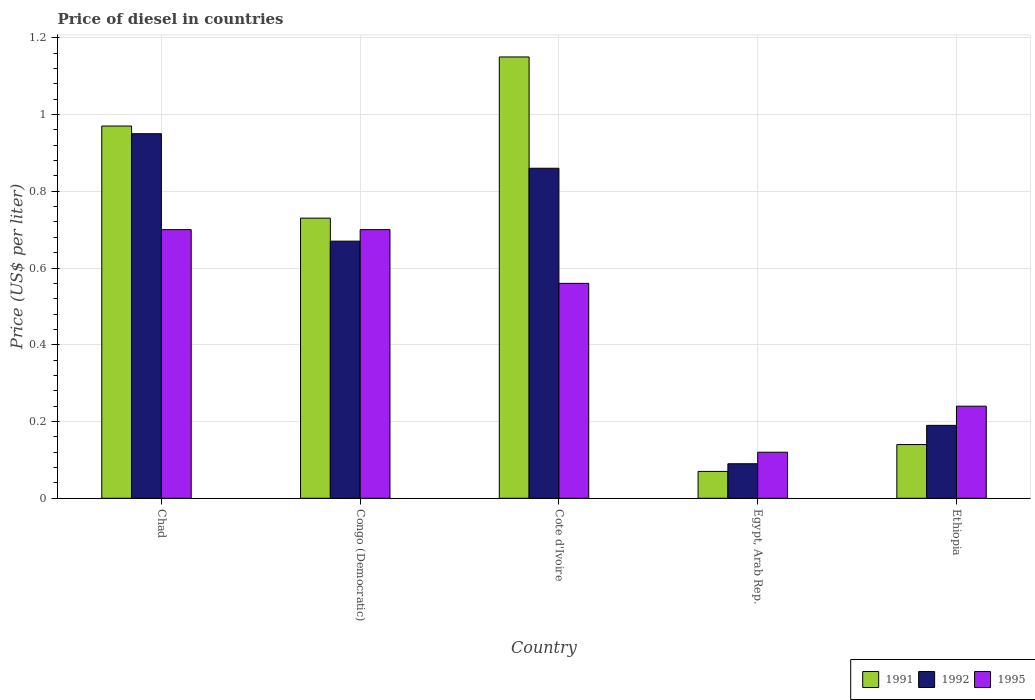How many different coloured bars are there?
Your answer should be very brief. 3. How many groups of bars are there?
Give a very brief answer. 5. Are the number of bars on each tick of the X-axis equal?
Your answer should be very brief. Yes. How many bars are there on the 4th tick from the left?
Keep it short and to the point. 3. How many bars are there on the 5th tick from the right?
Your answer should be compact. 3. What is the label of the 2nd group of bars from the left?
Provide a short and direct response. Congo (Democratic). In how many cases, is the number of bars for a given country not equal to the number of legend labels?
Offer a very short reply. 0. What is the price of diesel in 1995 in Egypt, Arab Rep.?
Your answer should be compact. 0.12. Across all countries, what is the minimum price of diesel in 1991?
Offer a very short reply. 0.07. In which country was the price of diesel in 1992 maximum?
Offer a very short reply. Chad. In which country was the price of diesel in 1991 minimum?
Your answer should be very brief. Egypt, Arab Rep. What is the total price of diesel in 1995 in the graph?
Offer a terse response. 2.32. What is the difference between the price of diesel in 1995 in Cote d'Ivoire and that in Egypt, Arab Rep.?
Offer a terse response. 0.44. What is the difference between the price of diesel in 1992 in Congo (Democratic) and the price of diesel in 1991 in Chad?
Ensure brevity in your answer.  -0.3. What is the average price of diesel in 1991 per country?
Offer a terse response. 0.61. What is the difference between the price of diesel of/in 1991 and price of diesel of/in 1992 in Cote d'Ivoire?
Keep it short and to the point. 0.29. In how many countries, is the price of diesel in 1991 greater than 0.12 US$?
Provide a succinct answer. 4. What is the ratio of the price of diesel in 1991 in Chad to that in Ethiopia?
Your answer should be very brief. 6.93. What is the difference between the highest and the second highest price of diesel in 1995?
Provide a short and direct response. 0.14. What is the difference between the highest and the lowest price of diesel in 1992?
Provide a short and direct response. 0.86. In how many countries, is the price of diesel in 1991 greater than the average price of diesel in 1991 taken over all countries?
Provide a succinct answer. 3. What does the 2nd bar from the left in Ethiopia represents?
Offer a very short reply. 1992. How many bars are there?
Offer a very short reply. 15. How many countries are there in the graph?
Make the answer very short. 5. What is the difference between two consecutive major ticks on the Y-axis?
Offer a very short reply. 0.2. How are the legend labels stacked?
Offer a very short reply. Horizontal. What is the title of the graph?
Keep it short and to the point. Price of diesel in countries. Does "2008" appear as one of the legend labels in the graph?
Make the answer very short. No. What is the label or title of the Y-axis?
Offer a terse response. Price (US$ per liter). What is the Price (US$ per liter) of 1991 in Chad?
Offer a very short reply. 0.97. What is the Price (US$ per liter) of 1992 in Chad?
Your answer should be compact. 0.95. What is the Price (US$ per liter) in 1991 in Congo (Democratic)?
Make the answer very short. 0.73. What is the Price (US$ per liter) in 1992 in Congo (Democratic)?
Keep it short and to the point. 0.67. What is the Price (US$ per liter) in 1995 in Congo (Democratic)?
Provide a succinct answer. 0.7. What is the Price (US$ per liter) of 1991 in Cote d'Ivoire?
Make the answer very short. 1.15. What is the Price (US$ per liter) of 1992 in Cote d'Ivoire?
Offer a terse response. 0.86. What is the Price (US$ per liter) in 1995 in Cote d'Ivoire?
Your answer should be compact. 0.56. What is the Price (US$ per liter) of 1991 in Egypt, Arab Rep.?
Your answer should be compact. 0.07. What is the Price (US$ per liter) in 1992 in Egypt, Arab Rep.?
Give a very brief answer. 0.09. What is the Price (US$ per liter) of 1995 in Egypt, Arab Rep.?
Make the answer very short. 0.12. What is the Price (US$ per liter) of 1991 in Ethiopia?
Provide a short and direct response. 0.14. What is the Price (US$ per liter) of 1992 in Ethiopia?
Offer a very short reply. 0.19. What is the Price (US$ per liter) of 1995 in Ethiopia?
Make the answer very short. 0.24. Across all countries, what is the maximum Price (US$ per liter) in 1991?
Ensure brevity in your answer.  1.15. Across all countries, what is the minimum Price (US$ per liter) in 1991?
Offer a very short reply. 0.07. Across all countries, what is the minimum Price (US$ per liter) of 1992?
Provide a short and direct response. 0.09. Across all countries, what is the minimum Price (US$ per liter) in 1995?
Your answer should be compact. 0.12. What is the total Price (US$ per liter) in 1991 in the graph?
Provide a short and direct response. 3.06. What is the total Price (US$ per liter) in 1992 in the graph?
Provide a short and direct response. 2.76. What is the total Price (US$ per liter) of 1995 in the graph?
Give a very brief answer. 2.32. What is the difference between the Price (US$ per liter) of 1991 in Chad and that in Congo (Democratic)?
Provide a short and direct response. 0.24. What is the difference between the Price (US$ per liter) in 1992 in Chad and that in Congo (Democratic)?
Provide a succinct answer. 0.28. What is the difference between the Price (US$ per liter) of 1991 in Chad and that in Cote d'Ivoire?
Provide a short and direct response. -0.18. What is the difference between the Price (US$ per liter) of 1992 in Chad and that in Cote d'Ivoire?
Your answer should be very brief. 0.09. What is the difference between the Price (US$ per liter) in 1995 in Chad and that in Cote d'Ivoire?
Your answer should be compact. 0.14. What is the difference between the Price (US$ per liter) of 1991 in Chad and that in Egypt, Arab Rep.?
Your answer should be very brief. 0.9. What is the difference between the Price (US$ per liter) in 1992 in Chad and that in Egypt, Arab Rep.?
Provide a succinct answer. 0.86. What is the difference between the Price (US$ per liter) in 1995 in Chad and that in Egypt, Arab Rep.?
Offer a terse response. 0.58. What is the difference between the Price (US$ per liter) of 1991 in Chad and that in Ethiopia?
Make the answer very short. 0.83. What is the difference between the Price (US$ per liter) in 1992 in Chad and that in Ethiopia?
Give a very brief answer. 0.76. What is the difference between the Price (US$ per liter) in 1995 in Chad and that in Ethiopia?
Your answer should be very brief. 0.46. What is the difference between the Price (US$ per liter) in 1991 in Congo (Democratic) and that in Cote d'Ivoire?
Offer a terse response. -0.42. What is the difference between the Price (US$ per liter) of 1992 in Congo (Democratic) and that in Cote d'Ivoire?
Ensure brevity in your answer.  -0.19. What is the difference between the Price (US$ per liter) of 1995 in Congo (Democratic) and that in Cote d'Ivoire?
Offer a very short reply. 0.14. What is the difference between the Price (US$ per liter) in 1991 in Congo (Democratic) and that in Egypt, Arab Rep.?
Your answer should be very brief. 0.66. What is the difference between the Price (US$ per liter) of 1992 in Congo (Democratic) and that in Egypt, Arab Rep.?
Offer a terse response. 0.58. What is the difference between the Price (US$ per liter) of 1995 in Congo (Democratic) and that in Egypt, Arab Rep.?
Provide a succinct answer. 0.58. What is the difference between the Price (US$ per liter) of 1991 in Congo (Democratic) and that in Ethiopia?
Provide a short and direct response. 0.59. What is the difference between the Price (US$ per liter) of 1992 in Congo (Democratic) and that in Ethiopia?
Provide a succinct answer. 0.48. What is the difference between the Price (US$ per liter) in 1995 in Congo (Democratic) and that in Ethiopia?
Offer a terse response. 0.46. What is the difference between the Price (US$ per liter) of 1991 in Cote d'Ivoire and that in Egypt, Arab Rep.?
Your response must be concise. 1.08. What is the difference between the Price (US$ per liter) in 1992 in Cote d'Ivoire and that in Egypt, Arab Rep.?
Keep it short and to the point. 0.77. What is the difference between the Price (US$ per liter) of 1995 in Cote d'Ivoire and that in Egypt, Arab Rep.?
Keep it short and to the point. 0.44. What is the difference between the Price (US$ per liter) in 1992 in Cote d'Ivoire and that in Ethiopia?
Keep it short and to the point. 0.67. What is the difference between the Price (US$ per liter) in 1995 in Cote d'Ivoire and that in Ethiopia?
Offer a very short reply. 0.32. What is the difference between the Price (US$ per liter) in 1991 in Egypt, Arab Rep. and that in Ethiopia?
Your answer should be compact. -0.07. What is the difference between the Price (US$ per liter) in 1995 in Egypt, Arab Rep. and that in Ethiopia?
Provide a succinct answer. -0.12. What is the difference between the Price (US$ per liter) of 1991 in Chad and the Price (US$ per liter) of 1995 in Congo (Democratic)?
Your answer should be very brief. 0.27. What is the difference between the Price (US$ per liter) in 1992 in Chad and the Price (US$ per liter) in 1995 in Congo (Democratic)?
Ensure brevity in your answer.  0.25. What is the difference between the Price (US$ per liter) in 1991 in Chad and the Price (US$ per liter) in 1992 in Cote d'Ivoire?
Your answer should be compact. 0.11. What is the difference between the Price (US$ per liter) in 1991 in Chad and the Price (US$ per liter) in 1995 in Cote d'Ivoire?
Your answer should be compact. 0.41. What is the difference between the Price (US$ per liter) in 1992 in Chad and the Price (US$ per liter) in 1995 in Cote d'Ivoire?
Your response must be concise. 0.39. What is the difference between the Price (US$ per liter) of 1991 in Chad and the Price (US$ per liter) of 1992 in Egypt, Arab Rep.?
Provide a short and direct response. 0.88. What is the difference between the Price (US$ per liter) in 1991 in Chad and the Price (US$ per liter) in 1995 in Egypt, Arab Rep.?
Your answer should be very brief. 0.85. What is the difference between the Price (US$ per liter) of 1992 in Chad and the Price (US$ per liter) of 1995 in Egypt, Arab Rep.?
Provide a succinct answer. 0.83. What is the difference between the Price (US$ per liter) of 1991 in Chad and the Price (US$ per liter) of 1992 in Ethiopia?
Provide a short and direct response. 0.78. What is the difference between the Price (US$ per liter) of 1991 in Chad and the Price (US$ per liter) of 1995 in Ethiopia?
Offer a very short reply. 0.73. What is the difference between the Price (US$ per liter) in 1992 in Chad and the Price (US$ per liter) in 1995 in Ethiopia?
Make the answer very short. 0.71. What is the difference between the Price (US$ per liter) in 1991 in Congo (Democratic) and the Price (US$ per liter) in 1992 in Cote d'Ivoire?
Your response must be concise. -0.13. What is the difference between the Price (US$ per liter) of 1991 in Congo (Democratic) and the Price (US$ per liter) of 1995 in Cote d'Ivoire?
Provide a short and direct response. 0.17. What is the difference between the Price (US$ per liter) in 1992 in Congo (Democratic) and the Price (US$ per liter) in 1995 in Cote d'Ivoire?
Your response must be concise. 0.11. What is the difference between the Price (US$ per liter) in 1991 in Congo (Democratic) and the Price (US$ per liter) in 1992 in Egypt, Arab Rep.?
Provide a short and direct response. 0.64. What is the difference between the Price (US$ per liter) of 1991 in Congo (Democratic) and the Price (US$ per liter) of 1995 in Egypt, Arab Rep.?
Your answer should be compact. 0.61. What is the difference between the Price (US$ per liter) of 1992 in Congo (Democratic) and the Price (US$ per liter) of 1995 in Egypt, Arab Rep.?
Provide a short and direct response. 0.55. What is the difference between the Price (US$ per liter) of 1991 in Congo (Democratic) and the Price (US$ per liter) of 1992 in Ethiopia?
Provide a short and direct response. 0.54. What is the difference between the Price (US$ per liter) of 1991 in Congo (Democratic) and the Price (US$ per liter) of 1995 in Ethiopia?
Provide a succinct answer. 0.49. What is the difference between the Price (US$ per liter) of 1992 in Congo (Democratic) and the Price (US$ per liter) of 1995 in Ethiopia?
Ensure brevity in your answer.  0.43. What is the difference between the Price (US$ per liter) in 1991 in Cote d'Ivoire and the Price (US$ per liter) in 1992 in Egypt, Arab Rep.?
Provide a succinct answer. 1.06. What is the difference between the Price (US$ per liter) of 1992 in Cote d'Ivoire and the Price (US$ per liter) of 1995 in Egypt, Arab Rep.?
Your answer should be very brief. 0.74. What is the difference between the Price (US$ per liter) of 1991 in Cote d'Ivoire and the Price (US$ per liter) of 1995 in Ethiopia?
Provide a short and direct response. 0.91. What is the difference between the Price (US$ per liter) in 1992 in Cote d'Ivoire and the Price (US$ per liter) in 1995 in Ethiopia?
Provide a succinct answer. 0.62. What is the difference between the Price (US$ per liter) of 1991 in Egypt, Arab Rep. and the Price (US$ per liter) of 1992 in Ethiopia?
Make the answer very short. -0.12. What is the difference between the Price (US$ per liter) in 1991 in Egypt, Arab Rep. and the Price (US$ per liter) in 1995 in Ethiopia?
Offer a terse response. -0.17. What is the difference between the Price (US$ per liter) in 1992 in Egypt, Arab Rep. and the Price (US$ per liter) in 1995 in Ethiopia?
Your answer should be compact. -0.15. What is the average Price (US$ per liter) of 1991 per country?
Your response must be concise. 0.61. What is the average Price (US$ per liter) in 1992 per country?
Keep it short and to the point. 0.55. What is the average Price (US$ per liter) in 1995 per country?
Ensure brevity in your answer.  0.46. What is the difference between the Price (US$ per liter) of 1991 and Price (US$ per liter) of 1992 in Chad?
Your response must be concise. 0.02. What is the difference between the Price (US$ per liter) in 1991 and Price (US$ per liter) in 1995 in Chad?
Your answer should be very brief. 0.27. What is the difference between the Price (US$ per liter) of 1992 and Price (US$ per liter) of 1995 in Chad?
Offer a very short reply. 0.25. What is the difference between the Price (US$ per liter) of 1991 and Price (US$ per liter) of 1992 in Congo (Democratic)?
Offer a very short reply. 0.06. What is the difference between the Price (US$ per liter) of 1992 and Price (US$ per liter) of 1995 in Congo (Democratic)?
Offer a terse response. -0.03. What is the difference between the Price (US$ per liter) in 1991 and Price (US$ per liter) in 1992 in Cote d'Ivoire?
Your answer should be compact. 0.29. What is the difference between the Price (US$ per liter) in 1991 and Price (US$ per liter) in 1995 in Cote d'Ivoire?
Ensure brevity in your answer.  0.59. What is the difference between the Price (US$ per liter) in 1992 and Price (US$ per liter) in 1995 in Cote d'Ivoire?
Your answer should be compact. 0.3. What is the difference between the Price (US$ per liter) of 1991 and Price (US$ per liter) of 1992 in Egypt, Arab Rep.?
Offer a very short reply. -0.02. What is the difference between the Price (US$ per liter) of 1992 and Price (US$ per liter) of 1995 in Egypt, Arab Rep.?
Offer a very short reply. -0.03. What is the difference between the Price (US$ per liter) of 1991 and Price (US$ per liter) of 1992 in Ethiopia?
Keep it short and to the point. -0.05. What is the ratio of the Price (US$ per liter) in 1991 in Chad to that in Congo (Democratic)?
Keep it short and to the point. 1.33. What is the ratio of the Price (US$ per liter) of 1992 in Chad to that in Congo (Democratic)?
Make the answer very short. 1.42. What is the ratio of the Price (US$ per liter) of 1995 in Chad to that in Congo (Democratic)?
Ensure brevity in your answer.  1. What is the ratio of the Price (US$ per liter) in 1991 in Chad to that in Cote d'Ivoire?
Offer a very short reply. 0.84. What is the ratio of the Price (US$ per liter) in 1992 in Chad to that in Cote d'Ivoire?
Make the answer very short. 1.1. What is the ratio of the Price (US$ per liter) of 1991 in Chad to that in Egypt, Arab Rep.?
Your answer should be compact. 13.86. What is the ratio of the Price (US$ per liter) of 1992 in Chad to that in Egypt, Arab Rep.?
Provide a short and direct response. 10.56. What is the ratio of the Price (US$ per liter) in 1995 in Chad to that in Egypt, Arab Rep.?
Keep it short and to the point. 5.83. What is the ratio of the Price (US$ per liter) of 1991 in Chad to that in Ethiopia?
Ensure brevity in your answer.  6.93. What is the ratio of the Price (US$ per liter) in 1992 in Chad to that in Ethiopia?
Provide a succinct answer. 5. What is the ratio of the Price (US$ per liter) in 1995 in Chad to that in Ethiopia?
Provide a short and direct response. 2.92. What is the ratio of the Price (US$ per liter) in 1991 in Congo (Democratic) to that in Cote d'Ivoire?
Your answer should be compact. 0.63. What is the ratio of the Price (US$ per liter) of 1992 in Congo (Democratic) to that in Cote d'Ivoire?
Provide a short and direct response. 0.78. What is the ratio of the Price (US$ per liter) of 1995 in Congo (Democratic) to that in Cote d'Ivoire?
Offer a very short reply. 1.25. What is the ratio of the Price (US$ per liter) in 1991 in Congo (Democratic) to that in Egypt, Arab Rep.?
Your answer should be very brief. 10.43. What is the ratio of the Price (US$ per liter) of 1992 in Congo (Democratic) to that in Egypt, Arab Rep.?
Provide a succinct answer. 7.44. What is the ratio of the Price (US$ per liter) in 1995 in Congo (Democratic) to that in Egypt, Arab Rep.?
Keep it short and to the point. 5.83. What is the ratio of the Price (US$ per liter) in 1991 in Congo (Democratic) to that in Ethiopia?
Give a very brief answer. 5.21. What is the ratio of the Price (US$ per liter) of 1992 in Congo (Democratic) to that in Ethiopia?
Ensure brevity in your answer.  3.53. What is the ratio of the Price (US$ per liter) of 1995 in Congo (Democratic) to that in Ethiopia?
Give a very brief answer. 2.92. What is the ratio of the Price (US$ per liter) in 1991 in Cote d'Ivoire to that in Egypt, Arab Rep.?
Provide a short and direct response. 16.43. What is the ratio of the Price (US$ per liter) in 1992 in Cote d'Ivoire to that in Egypt, Arab Rep.?
Provide a succinct answer. 9.56. What is the ratio of the Price (US$ per liter) of 1995 in Cote d'Ivoire to that in Egypt, Arab Rep.?
Your answer should be compact. 4.67. What is the ratio of the Price (US$ per liter) of 1991 in Cote d'Ivoire to that in Ethiopia?
Offer a terse response. 8.21. What is the ratio of the Price (US$ per liter) of 1992 in Cote d'Ivoire to that in Ethiopia?
Provide a short and direct response. 4.53. What is the ratio of the Price (US$ per liter) in 1995 in Cote d'Ivoire to that in Ethiopia?
Offer a terse response. 2.33. What is the ratio of the Price (US$ per liter) in 1992 in Egypt, Arab Rep. to that in Ethiopia?
Provide a succinct answer. 0.47. What is the ratio of the Price (US$ per liter) in 1995 in Egypt, Arab Rep. to that in Ethiopia?
Provide a short and direct response. 0.5. What is the difference between the highest and the second highest Price (US$ per liter) in 1991?
Make the answer very short. 0.18. What is the difference between the highest and the second highest Price (US$ per liter) in 1992?
Offer a very short reply. 0.09. What is the difference between the highest and the second highest Price (US$ per liter) in 1995?
Make the answer very short. 0. What is the difference between the highest and the lowest Price (US$ per liter) in 1991?
Make the answer very short. 1.08. What is the difference between the highest and the lowest Price (US$ per liter) in 1992?
Keep it short and to the point. 0.86. What is the difference between the highest and the lowest Price (US$ per liter) of 1995?
Ensure brevity in your answer.  0.58. 